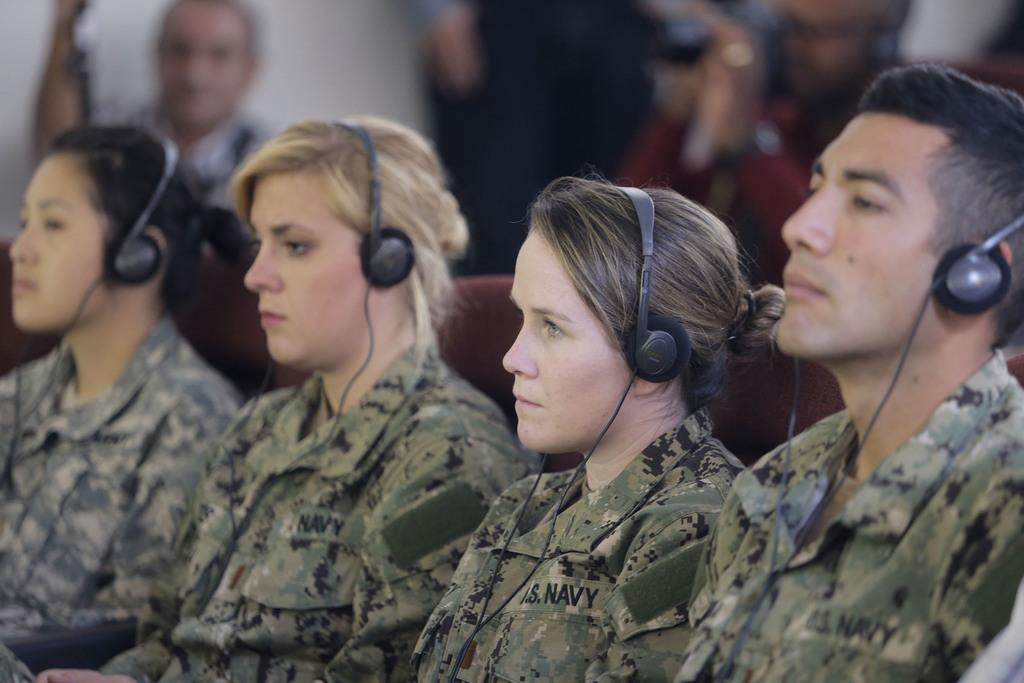In one or two sentences, can you explain what this image depicts? In this image we can see three women and one man with headphones and they are wearing uniform and sitting and the background is blurred with a person. 